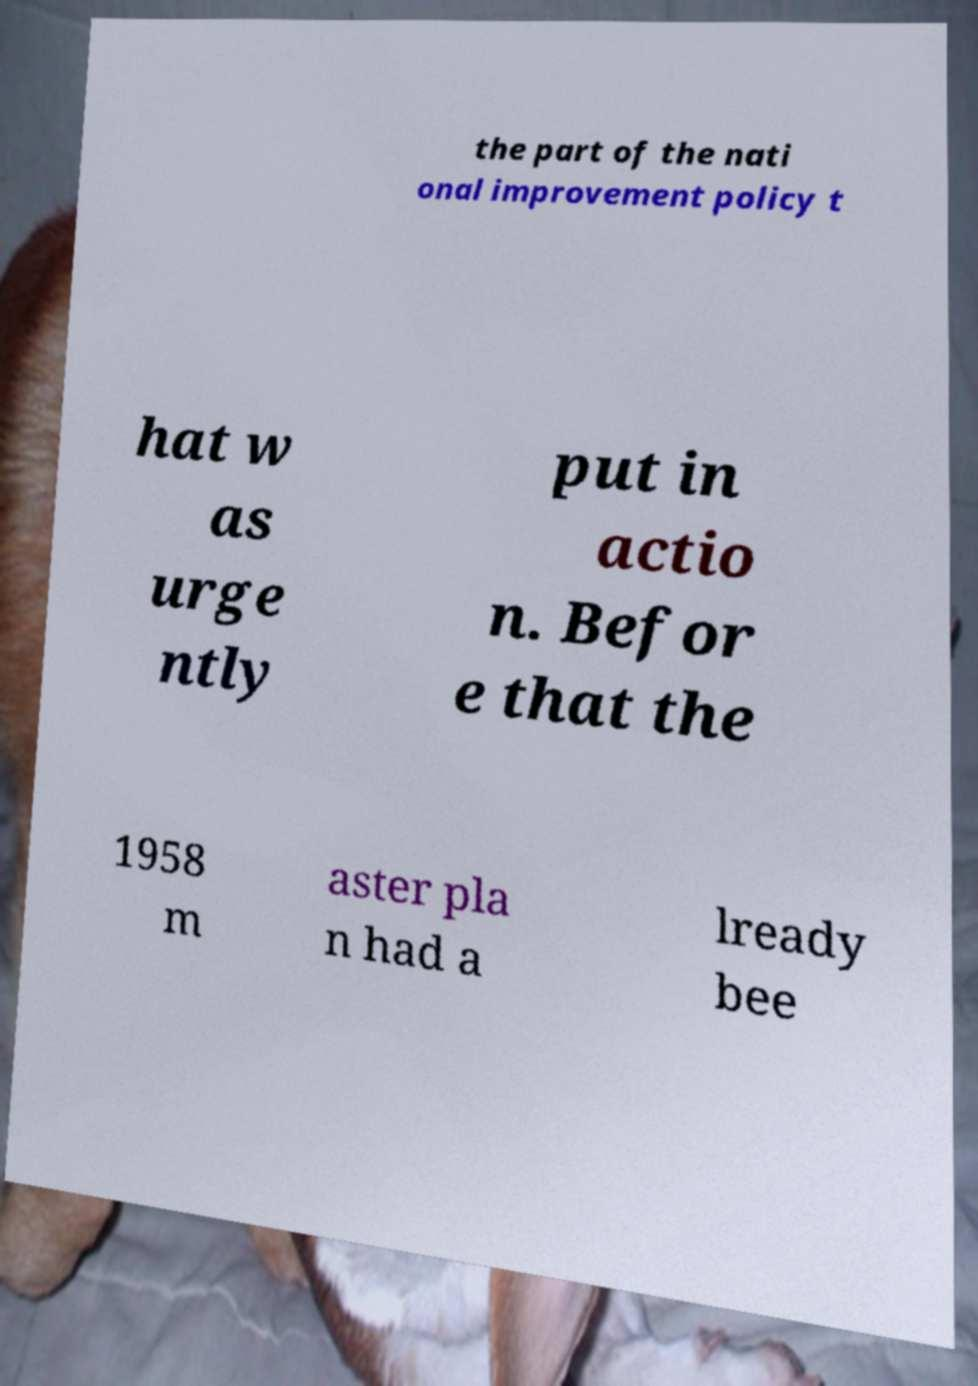Can you accurately transcribe the text from the provided image for me? the part of the nati onal improvement policy t hat w as urge ntly put in actio n. Befor e that the 1958 m aster pla n had a lready bee 